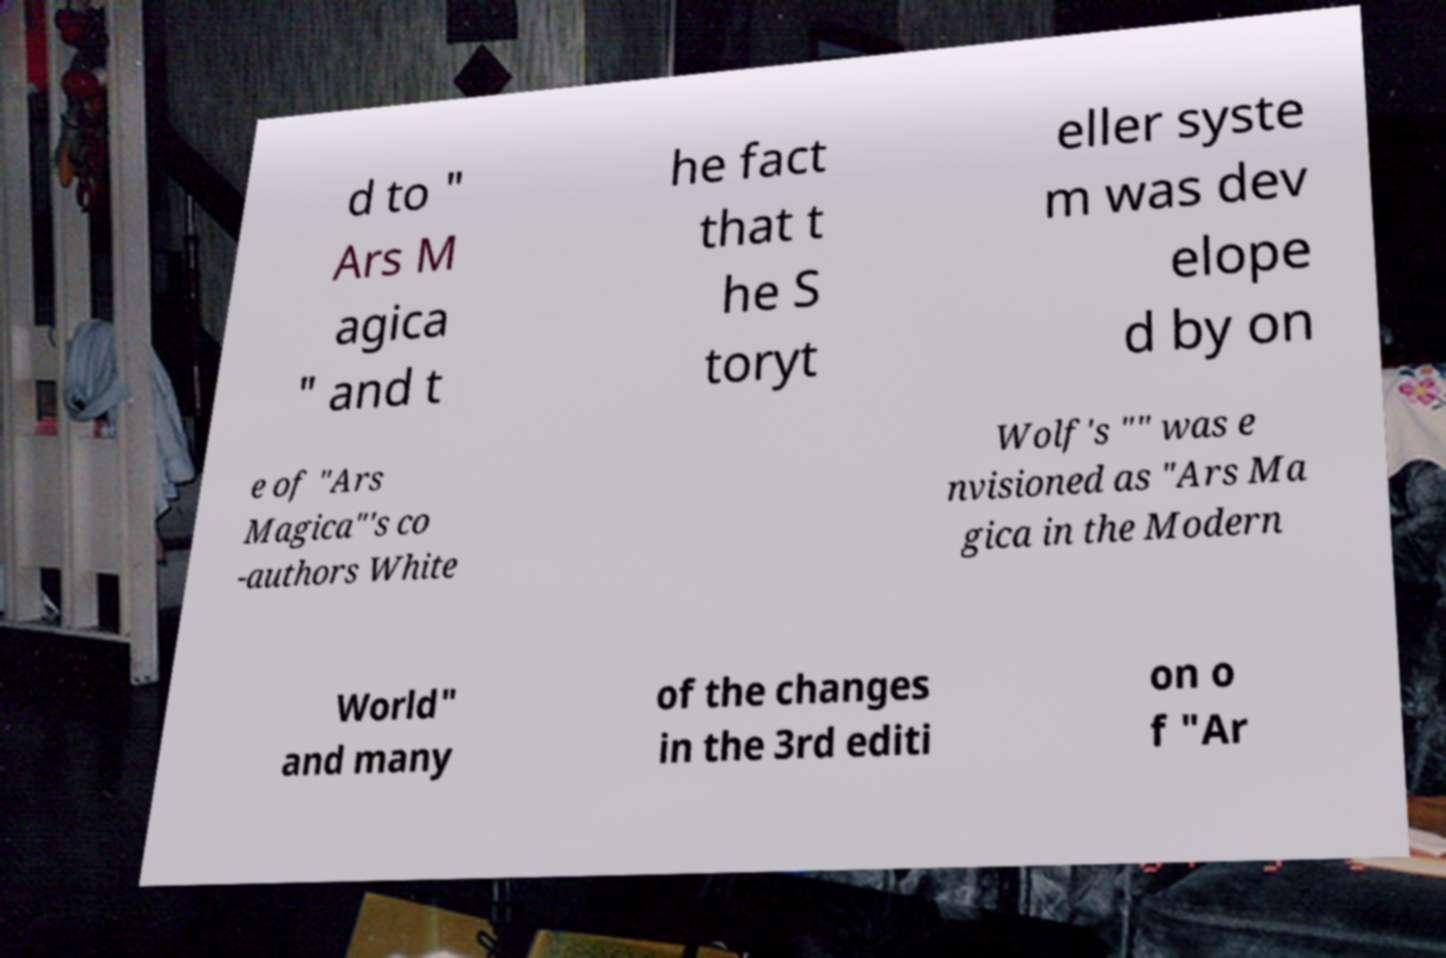Can you read and provide the text displayed in the image?This photo seems to have some interesting text. Can you extract and type it out for me? d to " Ars M agica " and t he fact that t he S toryt eller syste m was dev elope d by on e of "Ars Magica"'s co -authors White Wolf's "" was e nvisioned as "Ars Ma gica in the Modern World" and many of the changes in the 3rd editi on o f "Ar 